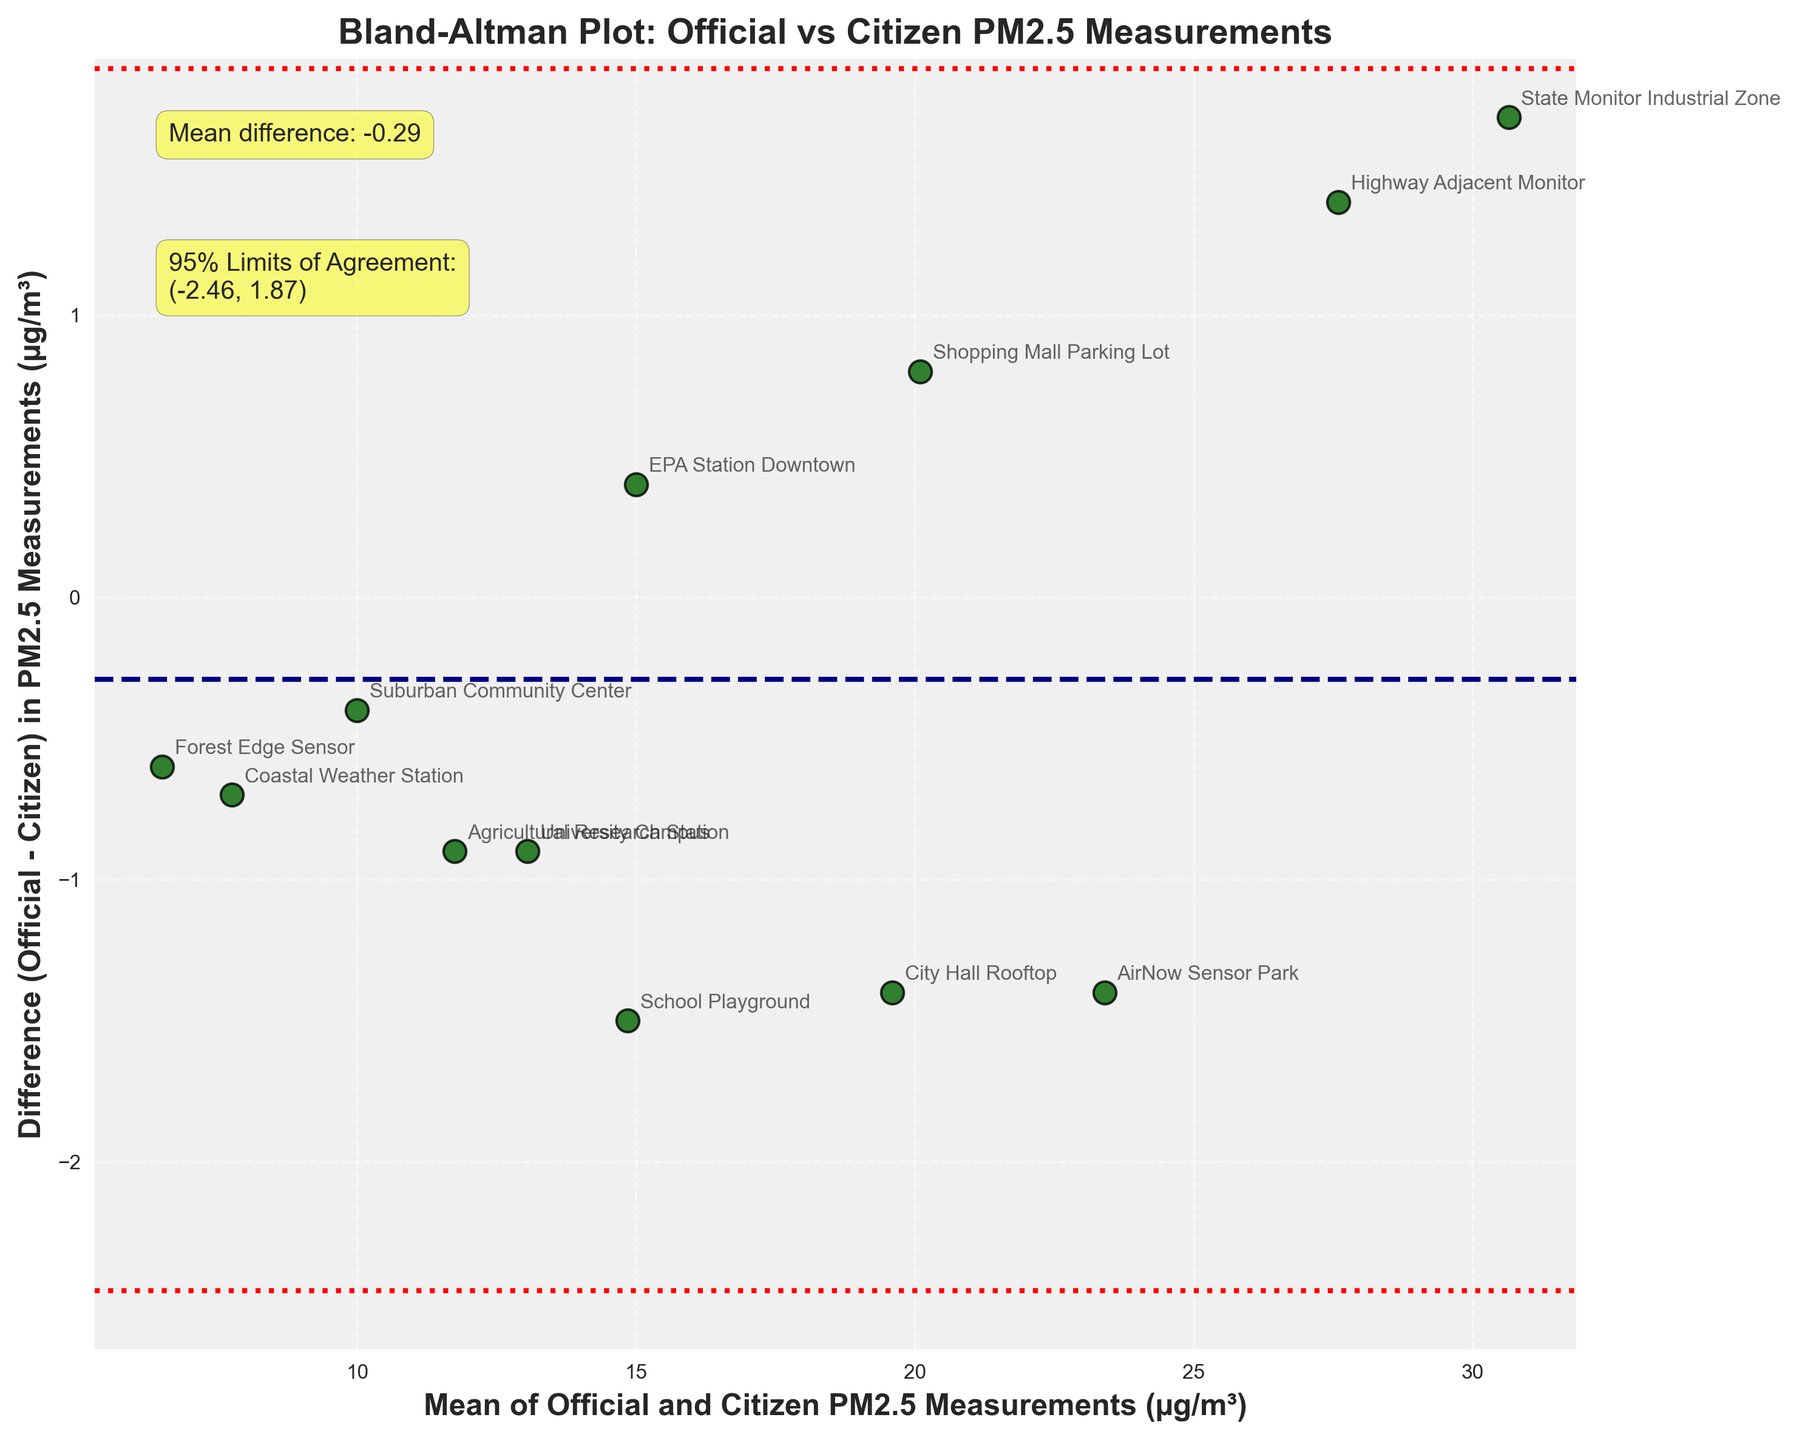What is the title of the plot? The title is usually written at the top of the plot. Here, "Bland-Altman Plot: Official vs Citizen PM2.5 Measurements" is written at the top in bold font.
Answer: Bland-Altman Plot: Official vs Citizen PM2.5 Measurements How many data points are plotted in the figure? Each data point is represented by a scatter point in the figure. By counting each point that is labeled, we can see there are 12 points.
Answer: 12 What are the x-axis and y-axis labels? The x-axis and y-axis labels are usually displayed along the respective axes. Here, the x-axis label is "Mean of Official and Citizen PM2.5 Measurements (µg/m³)" and the y-axis label is "Difference (Official - Citizen) in PM2.5 Measurements (µg/m³)".
Answer: Mean of Official and Citizen PM2.5 Measurements (µg/m³), Difference (Official - Citizen) in PM2.5 Measurements (µg/m³) What is the mean difference of PM2.5 measurements between the official and citizen stations? The mean difference is usually illustrated with a horizontal line and the value is annotated in the plot. Here, the mean difference is annotated as "Mean difference: -0.67".
Answer: -0.67 What are the 95% limits of agreement for the difference in PM2.5 measurements? The 95% limits of agreement are indicated with dashed lines and annotated in the plot. The plot annotates these limits as "-5.50" and "4.16".
Answer: -5.50, 4.16 Which official monitoring station shows the highest mean value of PM2.5 measurements? The mean values are plotted along the x-axis. The point farthest to the right corresponds to the highest mean value, which is for the "State Monitor Industrial Zone".
Answer: State Monitor Industrial Zone Which location has the smallest difference in PM2.5 measurements between the official and citizen stations? The smallest difference is the point closest to zero on the y-axis. Here, "EPA Station Downtown" shows the smallest difference.
Answer: EPA Station Downtown Is there a location where citizen measurements are consistently higher than official measurements? To answer this, we look for points with a positive y-axis value (official - citizen). "AirNow Sensor Park" and "City Hall Rooftop" have positive differences except the limit indicates one where citizen measurements are higher.
Answer: Yes How many locations have a positive difference where official measurements exceed citizen measurements? Points above the zero line on the y-axis represent locations with positive differences. By counting these points, we can see there are six such locations.
Answer: 6 Are there any data points that fall outside the 95% limits of agreement? Points that fall outside the dashed lines representing the 95% limits are outside the agreement range. Here, no points fall outside these lines, implying all points are within the limits.
Answer: No 